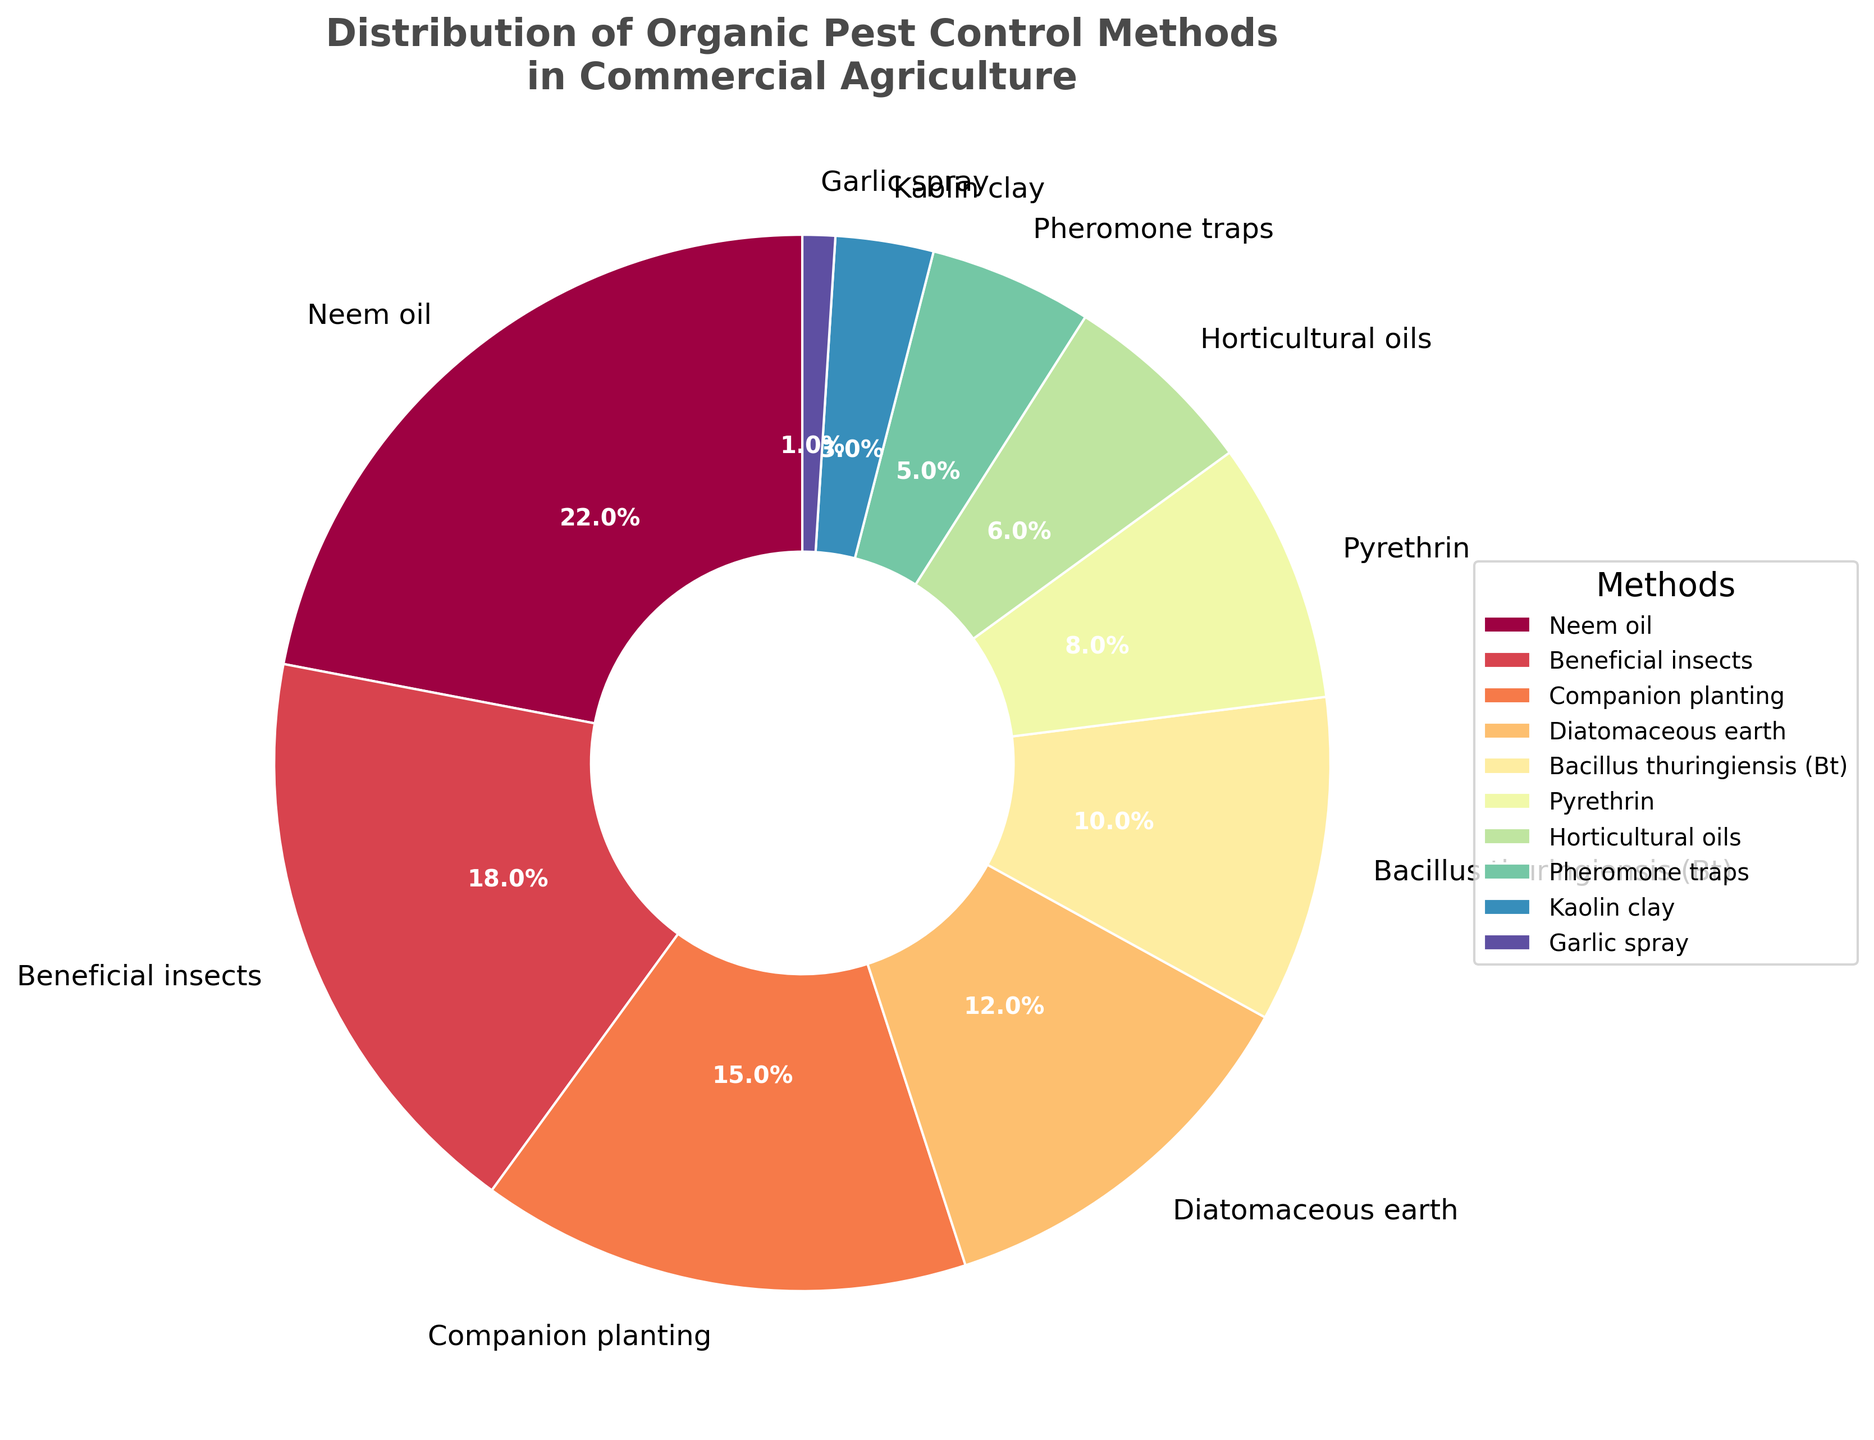Which method has the highest percentage usage? Neem oil has the highest usage since its wedge occupies the largest portion of the pie chart, labeled 22%.
Answer: Neem oil What is the combined percentage of Beneficial insects and Companion planting? Beneficial insects and Companion planting have percentages of 18% and 15% respectively. Adding these together gives 18% + 15% = 33%.
Answer: 33% Which method is used less frequently, Pheromone traps or Horticultural oils? Pheromone traps are used less frequently than Horticultural oils as they represent 5% of the chart and Horticultural oils represent 6%.
Answer: Pheromone traps What is the total percentage of all methods that are used less than 10% each? The methods used less than 10% each are Pyrethrin (8%), Horticultural oils (6%), Pheromone traps (5%), Kaolin clay (3%), and Garlic spray (1%). Summing these percentages gives 8% + 6% + 5% + 3% + 1% = 23%.
Answer: 23% How much greater is the percentage of Neem oil usage compared to Diatomaceous earth? Neem oil is 22% and Diatomaceous earth is 12%, so the difference is 22% - 12% = 10%.
Answer: 10% Which two methods combined have a percentage equal to or greater than Bacillus thuringiensis (Bt) usage? Bacillus thuringiensis (Bt) usage is 10%. Horticultural oils (6%) and Pheromone traps (5%) combined have a percentage of 6% + 5% = 11%, which is greater than 10%.
Answer: Horticultural oils and Pheromone traps Is the percentage of Companion planting closer to the percentage of Neem oil or Diatomaceous earth? Companion planting is 15%. The difference between Companion planting and Neem oil is 22% - 15% = 7%, whereas the difference between Companion planting and Diatomaceous earth is 15% - 12% = 3%. It is closer to Diatomaceous earth.
Answer: Diatomaceous earth Which methods make up more than half of the total usage combined? Methods that make up more than half (>50%) of the pie chart combined are Neem oil (22%), Beneficial insects (18%), and Companion planting (15%). Adding these together gives 22% + 18% + 15% = 55%.
Answer: Neem oil, Beneficial insects, and Companion planting 